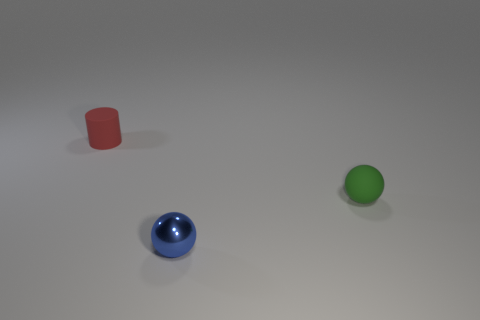Can you tell me what objects are present in the image? The image features three distinct objects: a red cylinder, a blue glossy sphere, and a green matte sphere. 